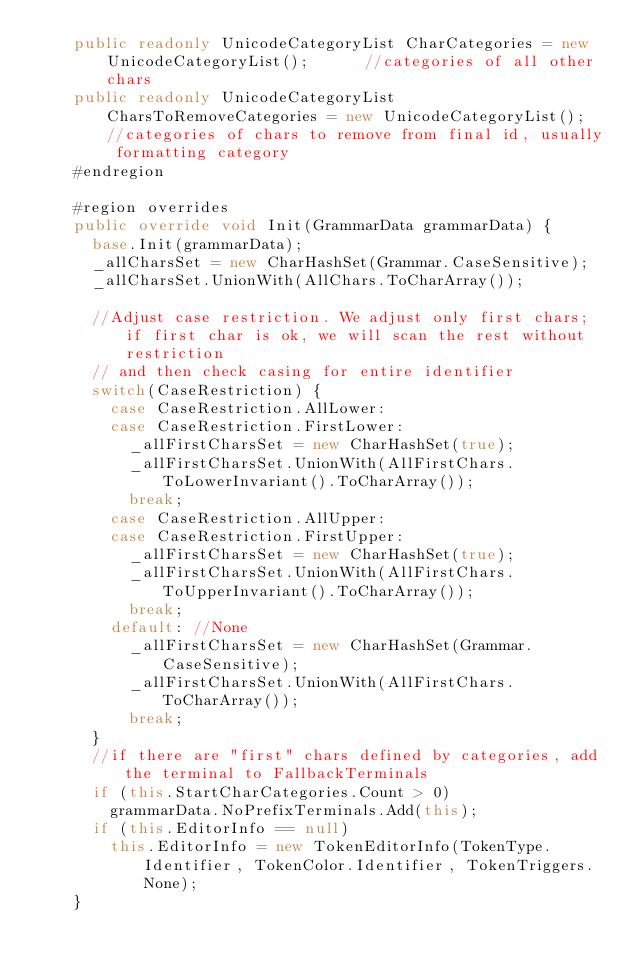<code> <loc_0><loc_0><loc_500><loc_500><_C#_>    public readonly UnicodeCategoryList CharCategories = new UnicodeCategoryList();      //categories of all other chars
    public readonly UnicodeCategoryList CharsToRemoveCategories = new UnicodeCategoryList(); //categories of chars to remove from final id, usually formatting category
    #endregion

    #region overrides
    public override void Init(GrammarData grammarData) {
      base.Init(grammarData);
      _allCharsSet = new CharHashSet(Grammar.CaseSensitive);
      _allCharsSet.UnionWith(AllChars.ToCharArray());

      //Adjust case restriction. We adjust only first chars; if first char is ok, we will scan the rest without restriction 
      // and then check casing for entire identifier
      switch(CaseRestriction) {
        case CaseRestriction.AllLower:
        case CaseRestriction.FirstLower:
          _allFirstCharsSet = new CharHashSet(true);
          _allFirstCharsSet.UnionWith(AllFirstChars.ToLowerInvariant().ToCharArray());
          break;
        case CaseRestriction.AllUpper:
        case CaseRestriction.FirstUpper:
          _allFirstCharsSet = new CharHashSet(true);
          _allFirstCharsSet.UnionWith(AllFirstChars.ToUpperInvariant().ToCharArray());
          break;
        default: //None
          _allFirstCharsSet = new CharHashSet(Grammar.CaseSensitive);
          _allFirstCharsSet.UnionWith(AllFirstChars.ToCharArray());
          break; 
      }
      //if there are "first" chars defined by categories, add the terminal to FallbackTerminals
      if (this.StartCharCategories.Count > 0)
        grammarData.NoPrefixTerminals.Add(this);
      if (this.EditorInfo == null) 
        this.EditorInfo = new TokenEditorInfo(TokenType.Identifier, TokenColor.Identifier, TokenTriggers.None);
    }
</code> 